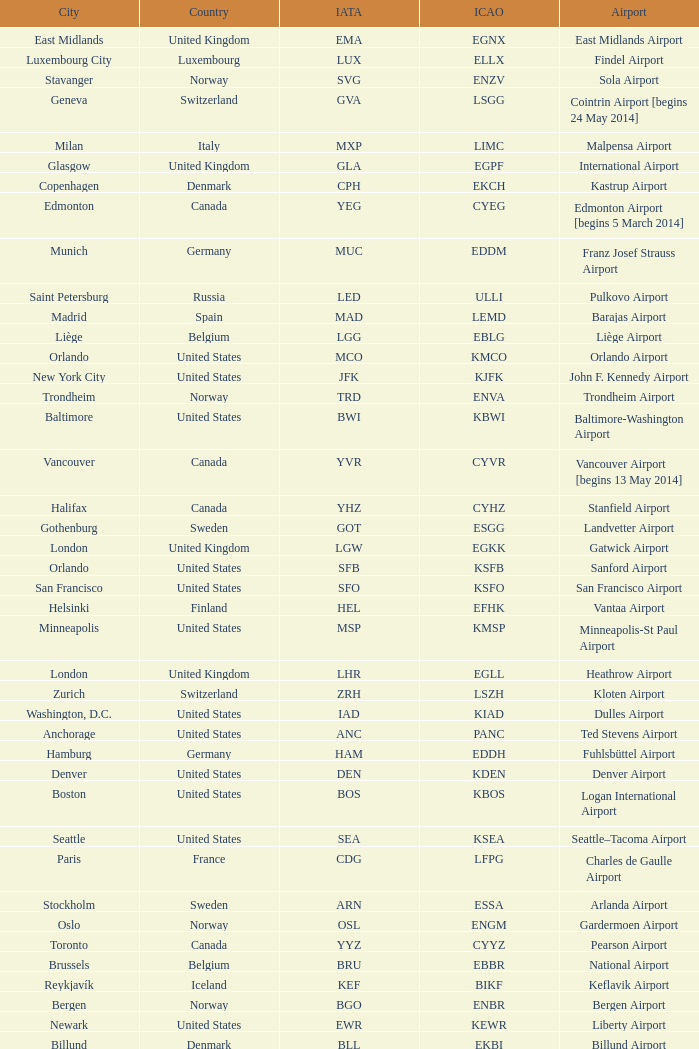What is the IATA OF Akureyri? AEY. 